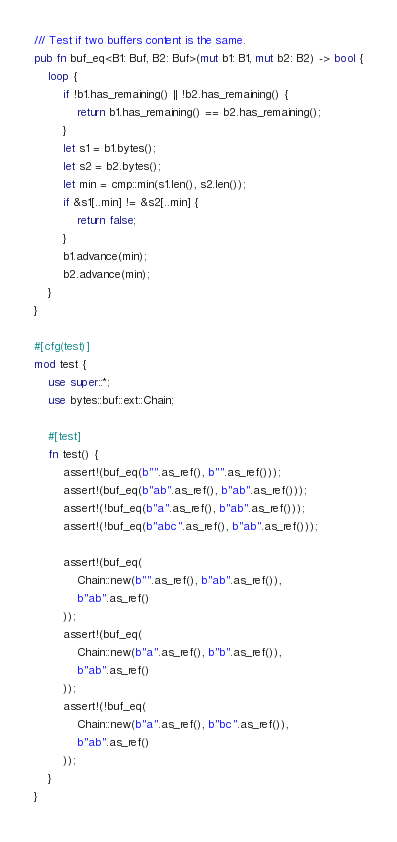Convert code to text. <code><loc_0><loc_0><loc_500><loc_500><_Rust_>/// Test if two buffers content is the same.
pub fn buf_eq<B1: Buf, B2: Buf>(mut b1: B1, mut b2: B2) -> bool {
    loop {
        if !b1.has_remaining() || !b2.has_remaining() {
            return b1.has_remaining() == b2.has_remaining();
        }
        let s1 = b1.bytes();
        let s2 = b2.bytes();
        let min = cmp::min(s1.len(), s2.len());
        if &s1[..min] != &s2[..min] {
            return false;
        }
        b1.advance(min);
        b2.advance(min);
    }
}

#[cfg(test)]
mod test {
    use super::*;
    use bytes::buf::ext::Chain;

    #[test]
    fn test() {
        assert!(buf_eq(b"".as_ref(), b"".as_ref()));
        assert!(buf_eq(b"ab".as_ref(), b"ab".as_ref()));
        assert!(!buf_eq(b"a".as_ref(), b"ab".as_ref()));
        assert!(!buf_eq(b"abc".as_ref(), b"ab".as_ref()));

        assert!(buf_eq(
            Chain::new(b"".as_ref(), b"ab".as_ref()),
            b"ab".as_ref()
        ));
        assert!(buf_eq(
            Chain::new(b"a".as_ref(), b"b".as_ref()),
            b"ab".as_ref()
        ));
        assert!(!buf_eq(
            Chain::new(b"a".as_ref(), b"bc".as_ref()),
            b"ab".as_ref()
        ));
    }
}
</code> 